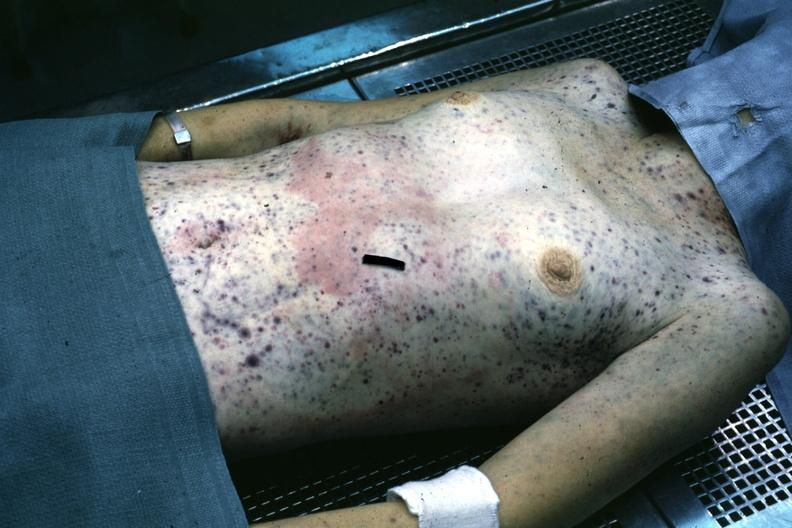does this image show but not good color many petechial and purpuric hemorrhages case of stcell leukemia?
Answer the question using a single word or phrase. Yes 